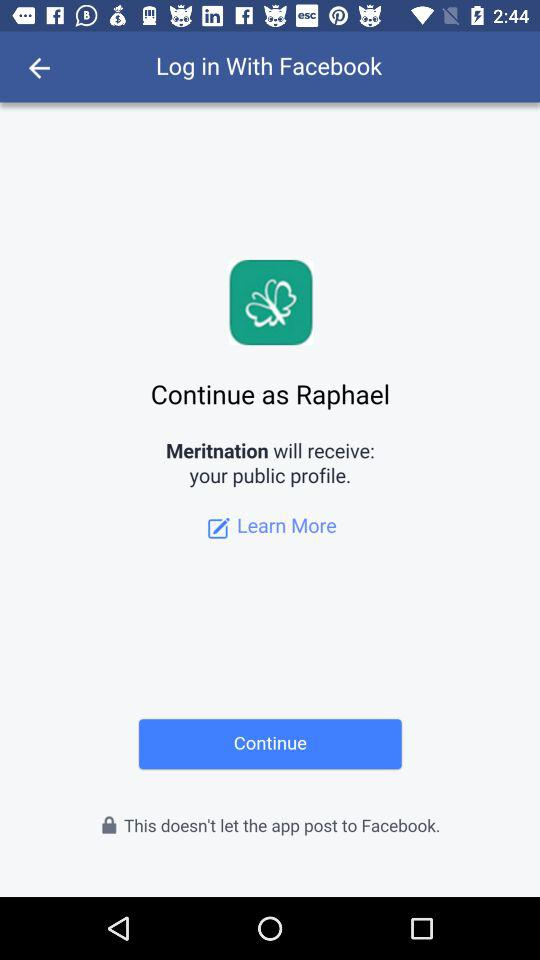What is the user name to continue on the login page? The user name to continue on the login page is Raphael. 